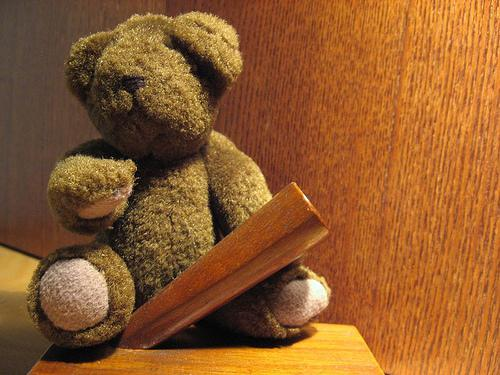Question: what color is the teddy bear?
Choices:
A. Blue.
B. Grey.
C. Brown.
D. Black.
Answer with the letter. Answer: C Question: who in the pictures doesn't have eyes?
Choices:
A. The ghost.
B. Teddy Bear.
C. The child.
D. The doll.
Answer with the letter. Answer: B Question: what material is the background?
Choices:
A. Plastic.
B. Wood.
C. Styrofoam.
D. Velvet.
Answer with the letter. Answer: B Question: how many ears does the teddy bear have?
Choices:
A. One.
B. None.
C. Three.
D. Two.
Answer with the letter. Answer: D Question: what side of the image is the teddy bear on?
Choices:
A. The bottom.
B. The right.
C. The left.
D. The top.
Answer with the letter. Answer: C 